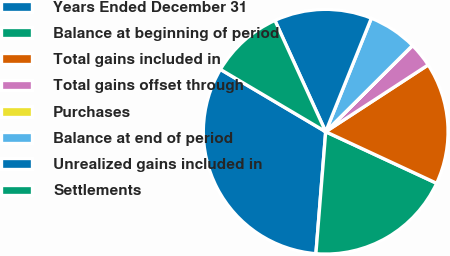Convert chart to OTSL. <chart><loc_0><loc_0><loc_500><loc_500><pie_chart><fcel>Years Ended December 31<fcel>Balance at beginning of period<fcel>Total gains included in<fcel>Total gains offset through<fcel>Purchases<fcel>Balance at end of period<fcel>Unrealized gains included in<fcel>Settlements<nl><fcel>32.23%<fcel>19.35%<fcel>16.12%<fcel>3.24%<fcel>0.02%<fcel>6.46%<fcel>12.9%<fcel>9.68%<nl></chart> 